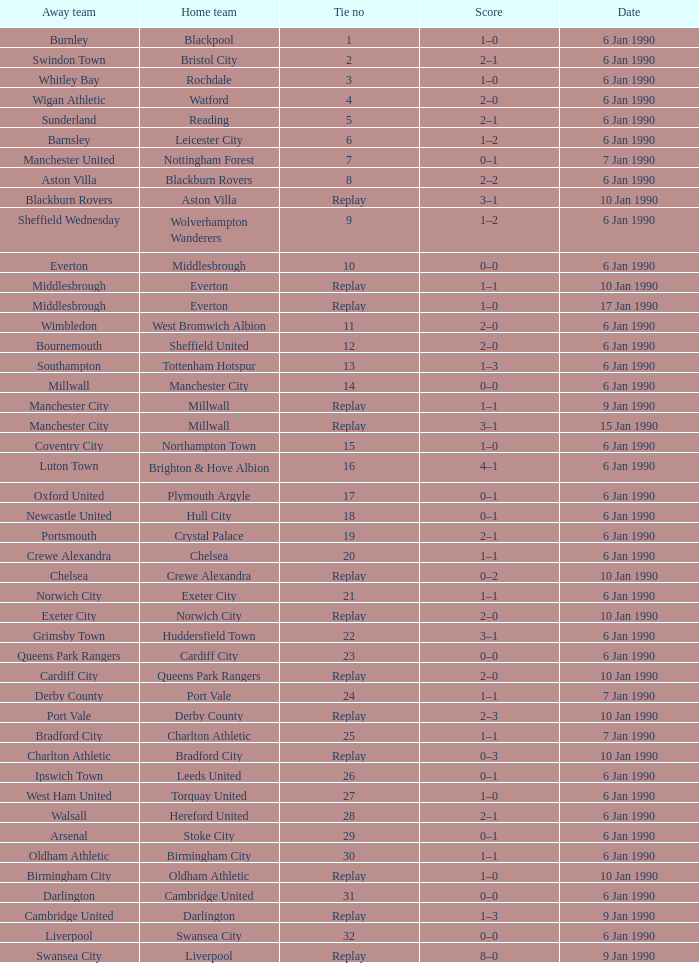What date did home team liverpool play? 9 Jan 1990. 